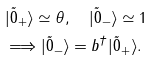Convert formula to latex. <formula><loc_0><loc_0><loc_500><loc_500>& | \tilde { 0 } _ { + } \rangle \simeq \theta , \quad | \tilde { 0 } _ { - } \rangle \simeq 1 \\ & \Longrightarrow | \tilde { 0 } _ { - } \rangle = b ^ { \dagger } | \tilde { 0 } _ { + } \rangle .</formula> 